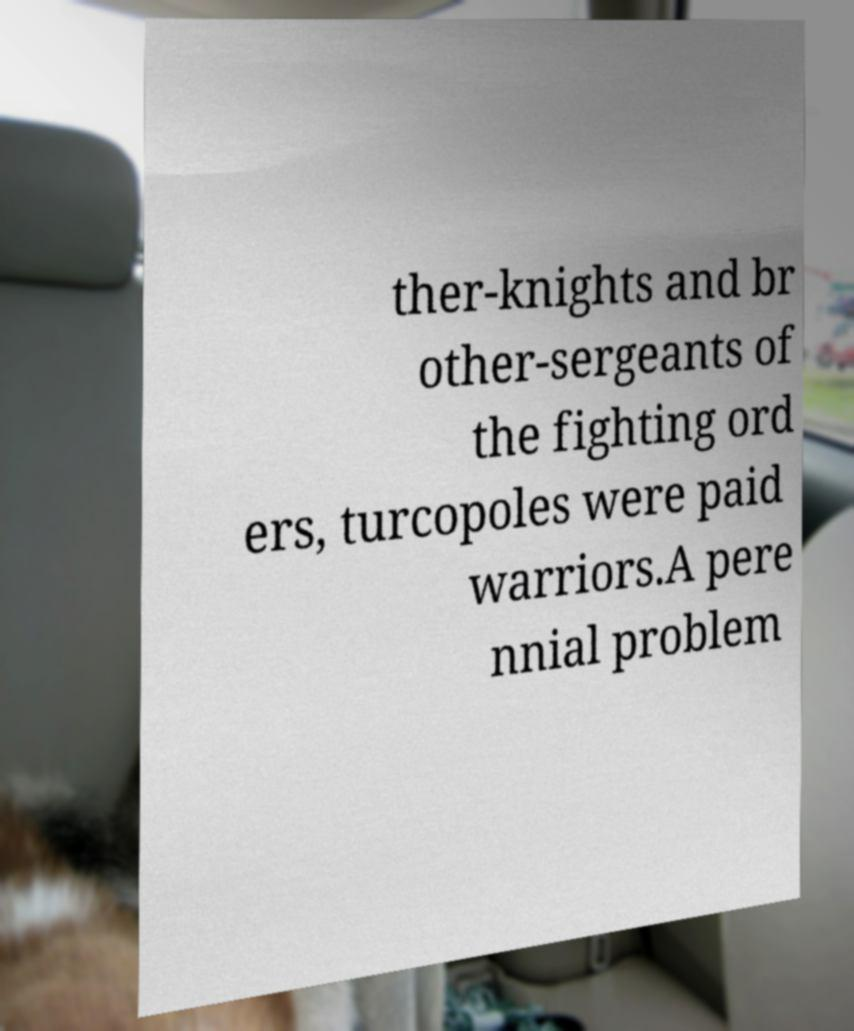Could you extract and type out the text from this image? ther-knights and br other-sergeants of the fighting ord ers, turcopoles were paid warriors.A pere nnial problem 